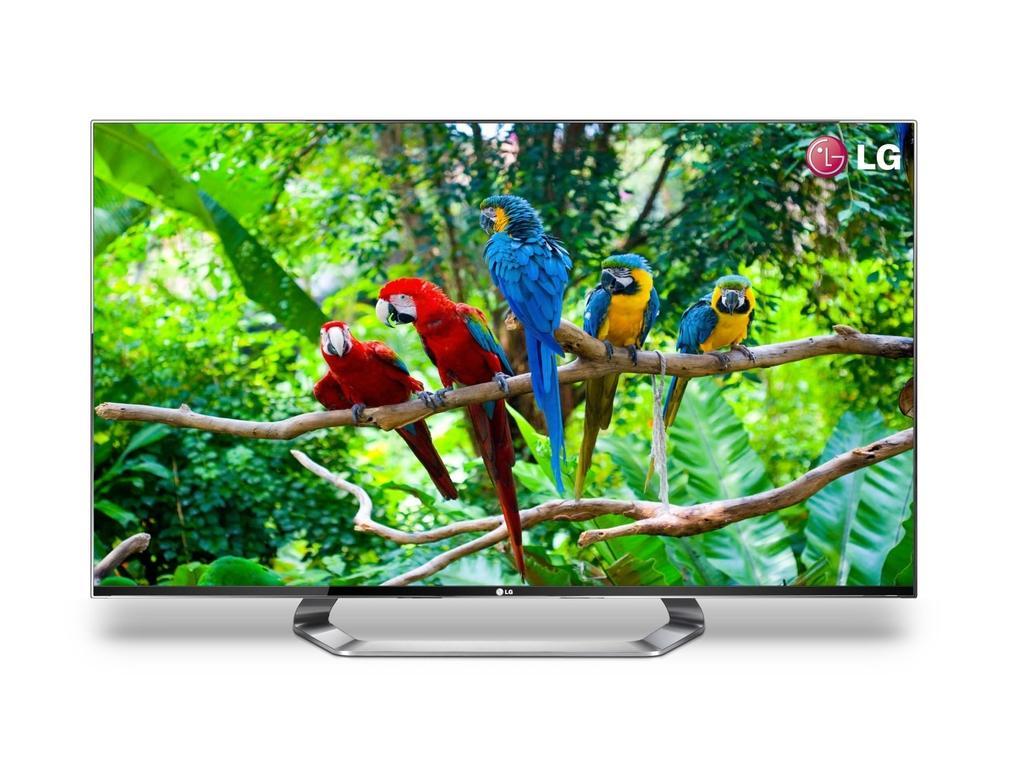In one or two sentences, can you explain what this image depicts? There is a picture on a television as we can see a group of parrot present on the stem which is in the middle of this image and there are trees in the background. There is a logo present in the top right corner of this image. 